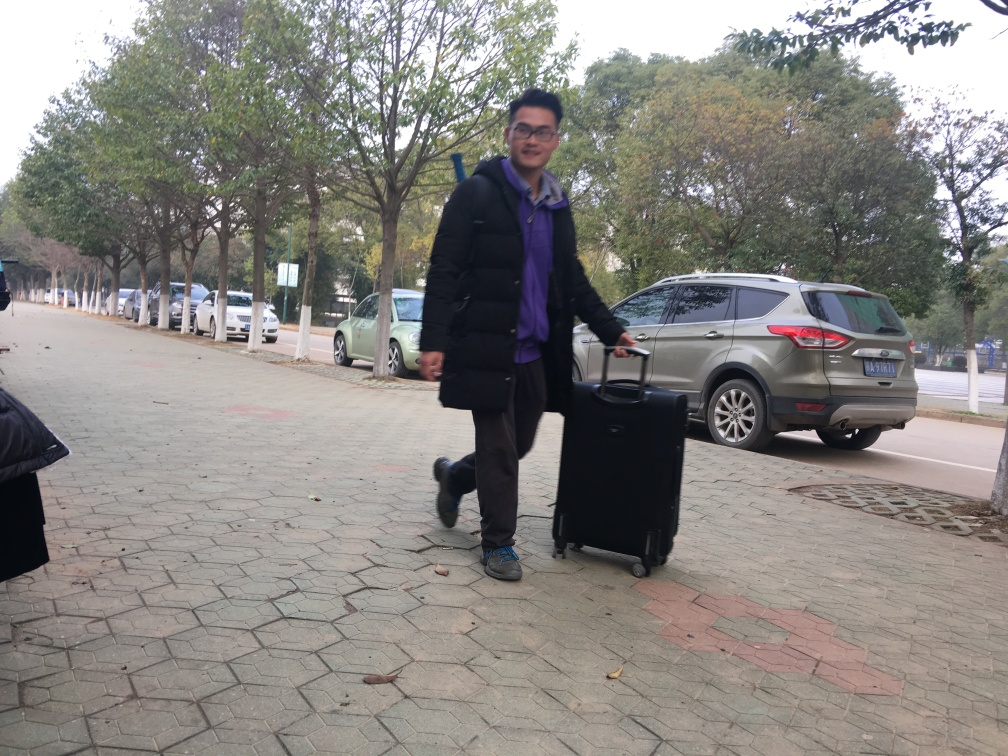Can you describe the person in this image? The person in the image is a smiling male wearing glasses. He's dressed in a dark winter jacket, purple scarf, jeans, and sporting dark shoes. He's in motion, pulling a suitcase behind him on a paved sidewalk lined with trees. What can you infer about the setting from the background? The background suggests an outdoor, possibly urban setting with trees lining a sidewalk. There are parked cars and SUVs, which hints at this being a parking lot or a street side parking area. It seems to be daytime with overcast lighting, indicating it might be a chilly or cold day. 